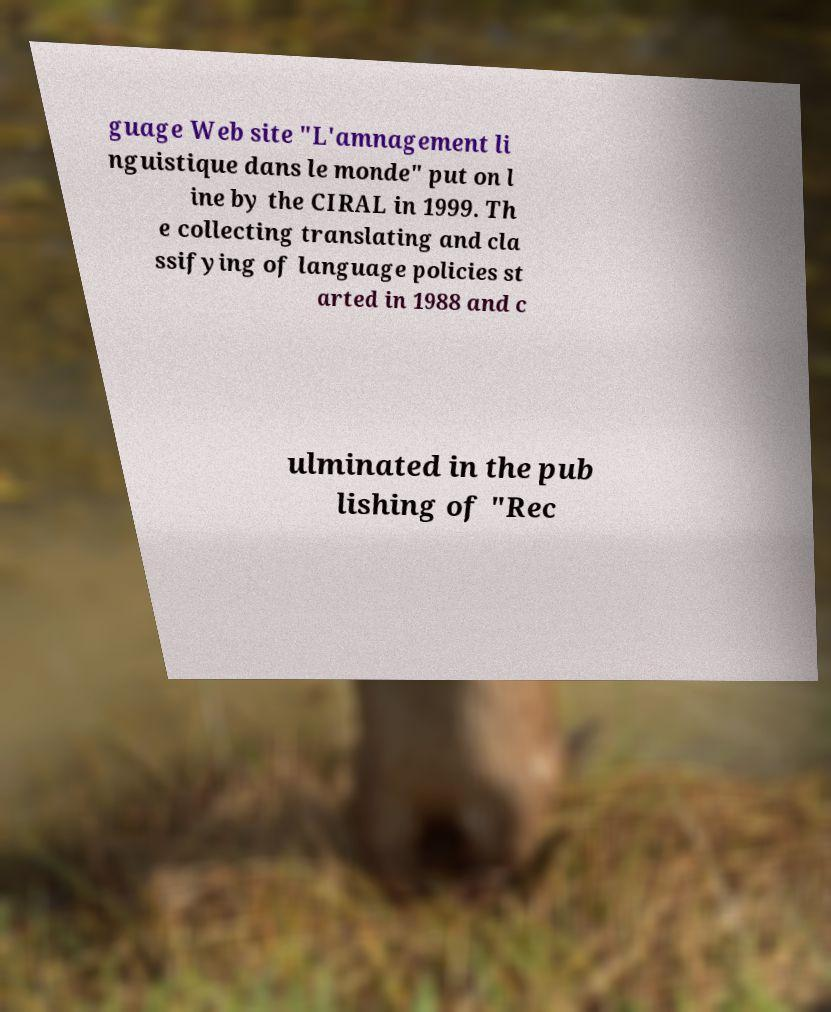Can you read and provide the text displayed in the image?This photo seems to have some interesting text. Can you extract and type it out for me? guage Web site "L'amnagement li nguistique dans le monde" put on l ine by the CIRAL in 1999. Th e collecting translating and cla ssifying of language policies st arted in 1988 and c ulminated in the pub lishing of "Rec 